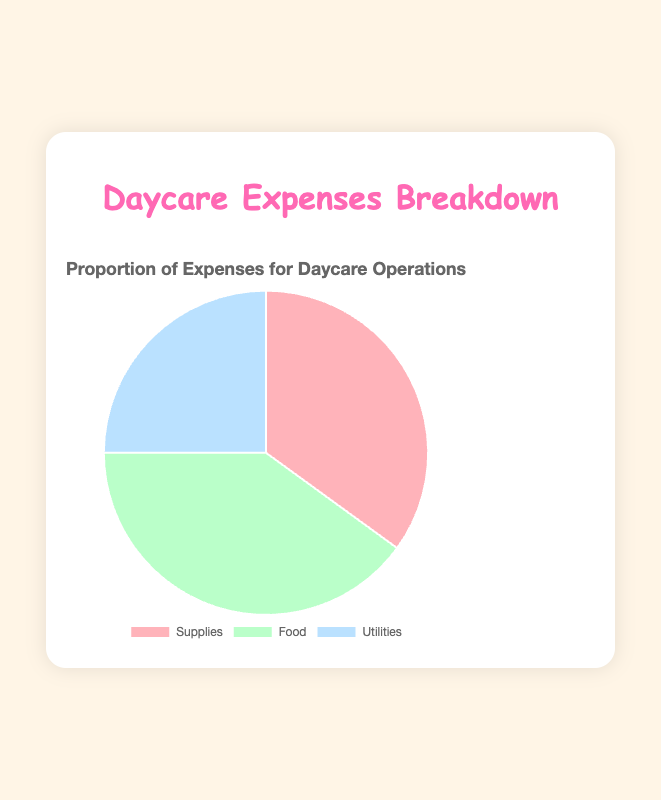What's the largest expense item for daycare operations? The largest component in the pie chart represents the highest percentage. Here, the "Food" section is the largest, comprising 40% of the expenses.
Answer: Food What is the total proportion of expenses for Supplies and Utilities combined? Adding the proportions of "Supplies" (35%) and "Utilities" (25%) gives the combined proportion. Therefore, 35% + 25% = 60%.
Answer: 60% Which expense category is the smallest? The smallest piece on the pie chart is the one corresponding to 25%, which is for "Utilities".
Answer: Utilities By how much is the expense for Food greater than the expense for Supplies? Subtract the proportion of "Supplies" (35%) from "Food" (40%) to find the difference, which is 40% - 35% = 5%.
Answer: 5% What percentage of expenses is not spent on Food? Subtract the Food expense (40%) from the total (100%) to find the remaining percentage: 100% - 40% = 60%.
Answer: 60% What's the average proportion of expenses across all categories? The average is calculated by summing all the category proportions (35% + 40% + 25% = 100%) and then dividing by the number of categories (3). So, 100% / 3 = 33.33%.
Answer: 33.33% What is the cumulative proportion of the two largest expense categories? The two largest categories are "Food" (40%) and "Supplies" (35%). Their cumulative proportion is 40% + 35% = 75%.
Answer: 75% What color represents the Supplies category? The pie chart's color for "Supplies" is a specific shade to distinguish it from other categories. Here, it is represented by a pinkish-red color.
Answer: pinkish-red Out of Supplies and Utilities, which category has a higher expense proportion and by how much? Comparing both, "Supplies" has a higher proportion (35%) than "Utilities" (25%). The difference is 35% - 25% = 10%.
Answer: Supplies by 10% Which expense category's color changes to a specific shade of blue when hovered over? The "Utilities" category changes to a specific shade of blue (hover color) when hovered over the pie chart.
Answer: Utilities 